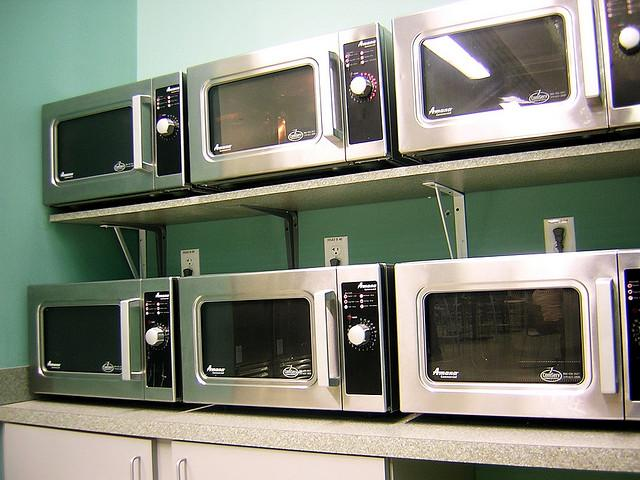Why are there so many microwaves? for sale 